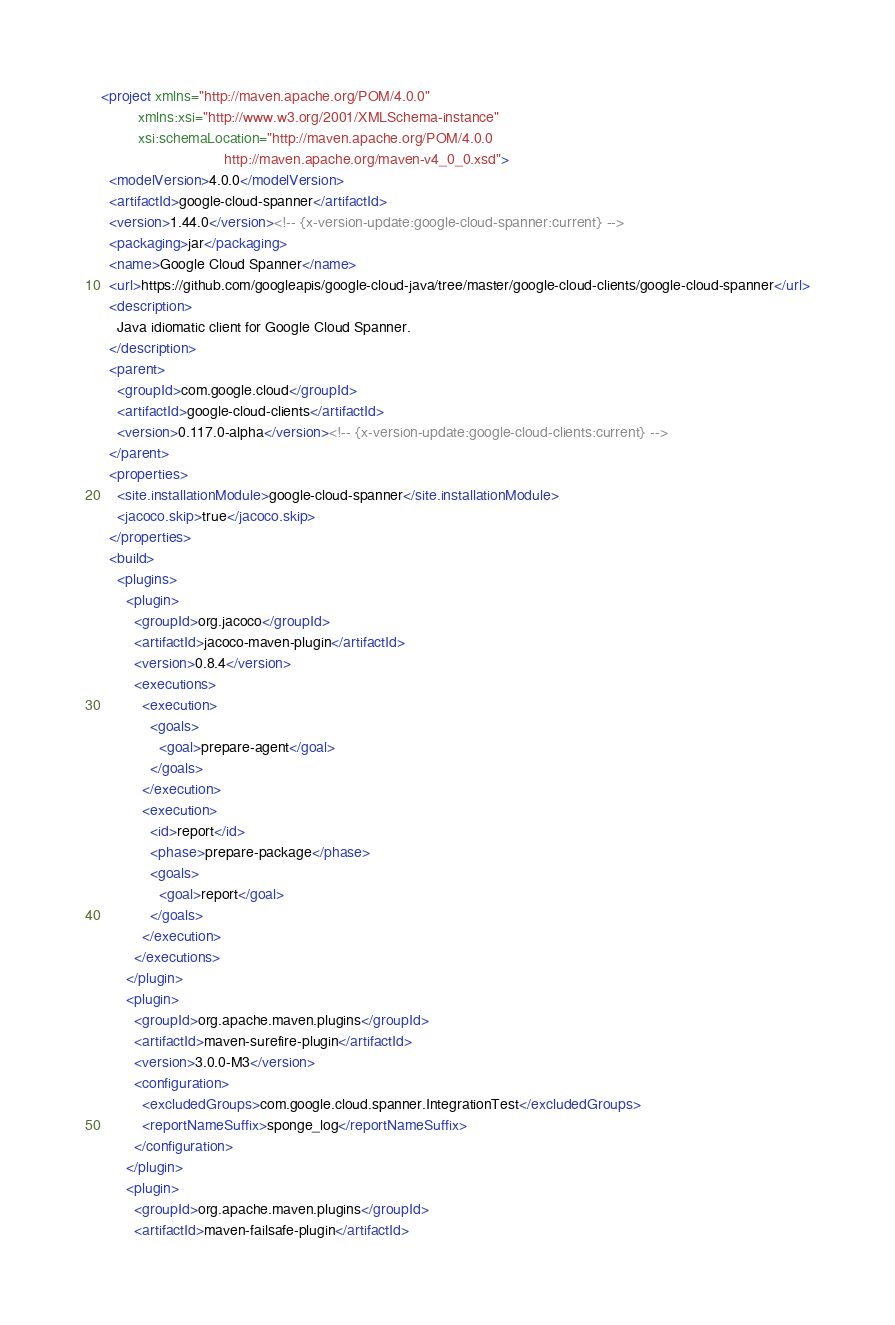Convert code to text. <code><loc_0><loc_0><loc_500><loc_500><_XML_><project xmlns="http://maven.apache.org/POM/4.0.0"
         xmlns:xsi="http://www.w3.org/2001/XMLSchema-instance"
         xsi:schemaLocation="http://maven.apache.org/POM/4.0.0
                              http://maven.apache.org/maven-v4_0_0.xsd">
  <modelVersion>4.0.0</modelVersion>
  <artifactId>google-cloud-spanner</artifactId>
  <version>1.44.0</version><!-- {x-version-update:google-cloud-spanner:current} -->
  <packaging>jar</packaging>
  <name>Google Cloud Spanner</name>
  <url>https://github.com/googleapis/google-cloud-java/tree/master/google-cloud-clients/google-cloud-spanner</url>
  <description>
    Java idiomatic client for Google Cloud Spanner.
  </description>
  <parent>
    <groupId>com.google.cloud</groupId>
    <artifactId>google-cloud-clients</artifactId>
    <version>0.117.0-alpha</version><!-- {x-version-update:google-cloud-clients:current} -->
  </parent>
  <properties>
    <site.installationModule>google-cloud-spanner</site.installationModule>
    <jacoco.skip>true</jacoco.skip>
  </properties>
  <build>
    <plugins>
      <plugin>
        <groupId>org.jacoco</groupId>
        <artifactId>jacoco-maven-plugin</artifactId>
        <version>0.8.4</version>
        <executions>
          <execution>
            <goals>
              <goal>prepare-agent</goal>
            </goals>
          </execution>
          <execution>
            <id>report</id>
            <phase>prepare-package</phase>
            <goals>
              <goal>report</goal>
            </goals>
          </execution>
        </executions>
      </plugin>
      <plugin>
        <groupId>org.apache.maven.plugins</groupId>
        <artifactId>maven-surefire-plugin</artifactId>
        <version>3.0.0-M3</version>
        <configuration>
          <excludedGroups>com.google.cloud.spanner.IntegrationTest</excludedGroups>
          <reportNameSuffix>sponge_log</reportNameSuffix>
        </configuration>
      </plugin>
      <plugin>
        <groupId>org.apache.maven.plugins</groupId>
        <artifactId>maven-failsafe-plugin</artifactId></code> 